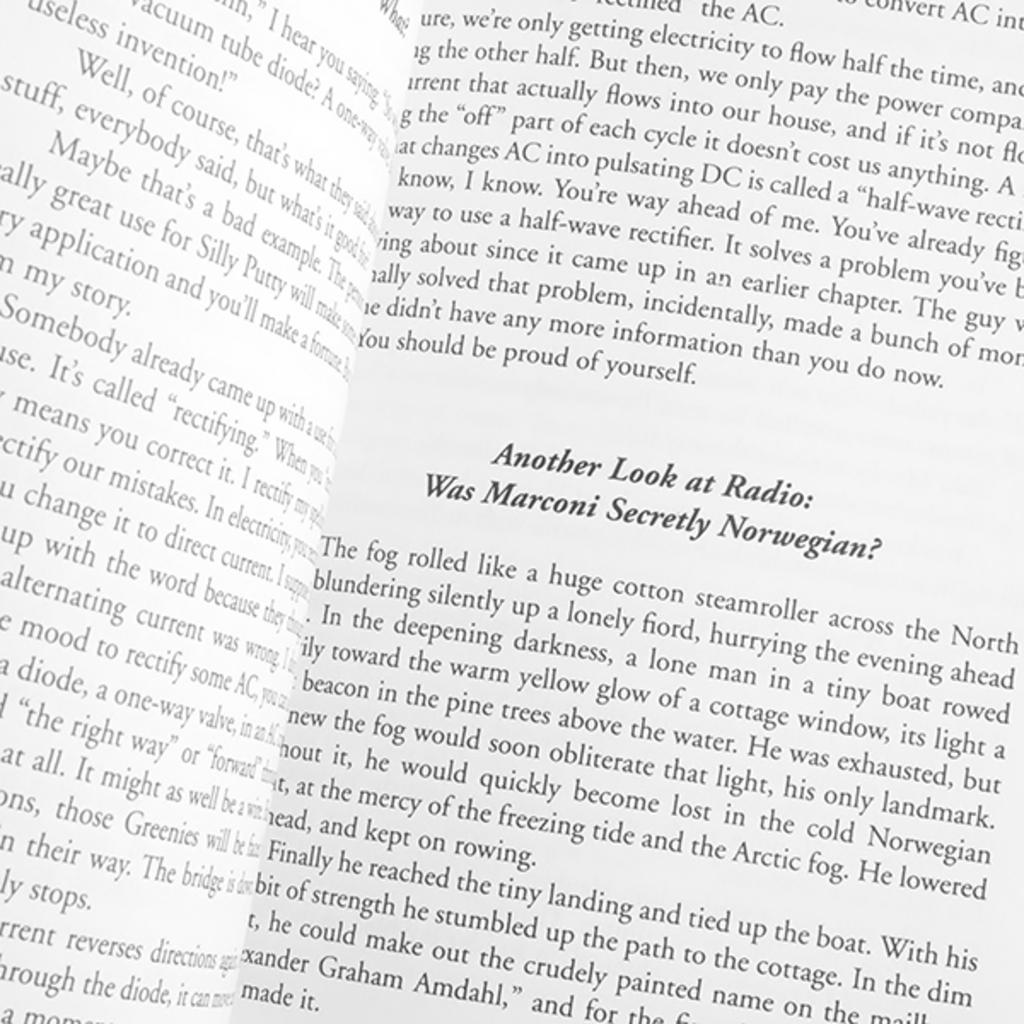<image>
Describe the image concisely. Open book on a page that says "Another Look at Radio". 